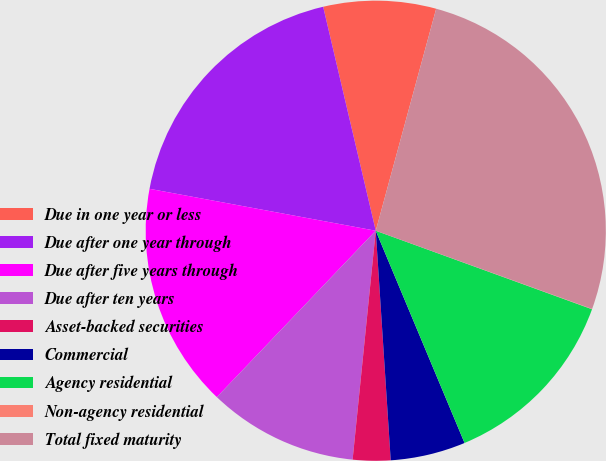<chart> <loc_0><loc_0><loc_500><loc_500><pie_chart><fcel>Due in one year or less<fcel>Due after one year through<fcel>Due after five years through<fcel>Due after ten years<fcel>Asset-backed securities<fcel>Commercial<fcel>Agency residential<fcel>Non-agency residential<fcel>Total fixed maturity<nl><fcel>7.9%<fcel>18.41%<fcel>15.78%<fcel>10.53%<fcel>2.64%<fcel>5.27%<fcel>13.15%<fcel>0.02%<fcel>26.29%<nl></chart> 